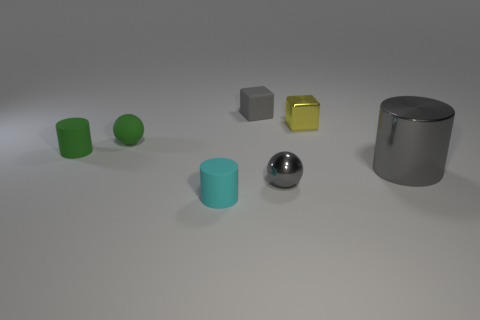Is there any other thing that is the same size as the cyan matte cylinder?
Your answer should be very brief. Yes. Do the cyan object and the small gray sphere have the same material?
Ensure brevity in your answer.  No. There is a cylinder on the right side of the small gray block; does it have the same size as the thing in front of the gray shiny ball?
Ensure brevity in your answer.  No. Are there fewer tiny green cylinders than brown objects?
Offer a very short reply. No. How many rubber things are tiny spheres or tiny cyan objects?
Offer a very short reply. 2. There is a gray shiny thing in front of the shiny cylinder; are there any tiny gray things that are on the left side of it?
Your answer should be very brief. Yes. Does the ball that is in front of the tiny matte sphere have the same material as the tiny green sphere?
Your answer should be very brief. No. How many other objects are the same color as the big metallic thing?
Offer a terse response. 2. Does the big cylinder have the same color as the small metallic cube?
Your response must be concise. No. There is a cylinder that is right of the tiny cylinder that is in front of the big gray metal object; what is its size?
Provide a succinct answer. Large. 